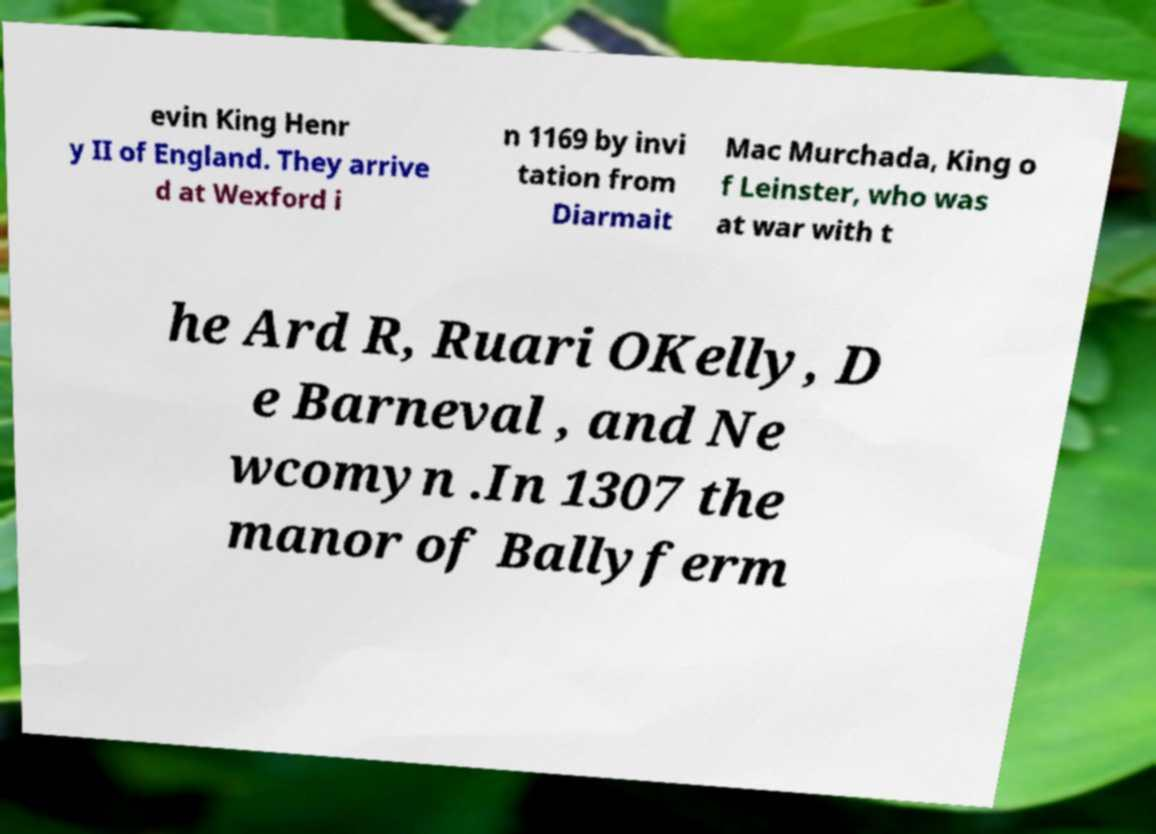What messages or text are displayed in this image? I need them in a readable, typed format. evin King Henr y II of England. They arrive d at Wexford i n 1169 by invi tation from Diarmait Mac Murchada, King o f Leinster, who was at war with t he Ard R, Ruari OKelly, D e Barneval , and Ne wcomyn .In 1307 the manor of Ballyferm 